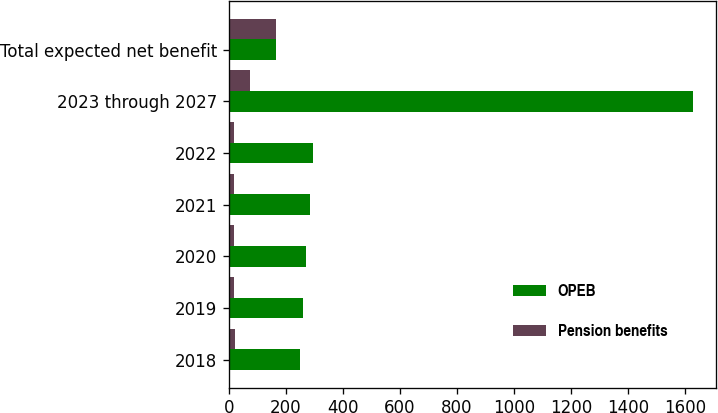Convert chart to OTSL. <chart><loc_0><loc_0><loc_500><loc_500><stacked_bar_chart><ecel><fcel>2018<fcel>2019<fcel>2020<fcel>2021<fcel>2022<fcel>2023 through 2027<fcel>Total expected net benefit<nl><fcel>OPEB<fcel>250<fcel>260<fcel>271<fcel>283<fcel>294<fcel>1626<fcel>164<nl><fcel>Pension benefits<fcel>20<fcel>19<fcel>18<fcel>17<fcel>17<fcel>73<fcel>164<nl></chart> 